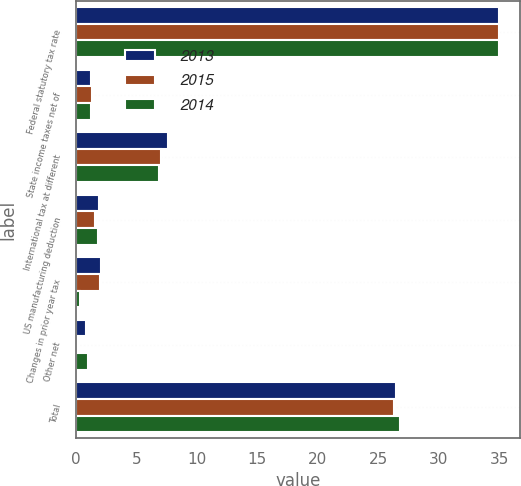<chart> <loc_0><loc_0><loc_500><loc_500><stacked_bar_chart><ecel><fcel>Federal statutory tax rate<fcel>State income taxes net of<fcel>International tax at different<fcel>US manufacturing deduction<fcel>Changes in prior year tax<fcel>Other net<fcel>Total<nl><fcel>2013<fcel>35<fcel>1.2<fcel>7.6<fcel>1.9<fcel>2.1<fcel>0.8<fcel>26.5<nl><fcel>2015<fcel>35<fcel>1.3<fcel>7<fcel>1.6<fcel>2<fcel>0.2<fcel>26.3<nl><fcel>2014<fcel>35<fcel>1.2<fcel>6.9<fcel>1.8<fcel>0.3<fcel>1<fcel>26.8<nl></chart> 